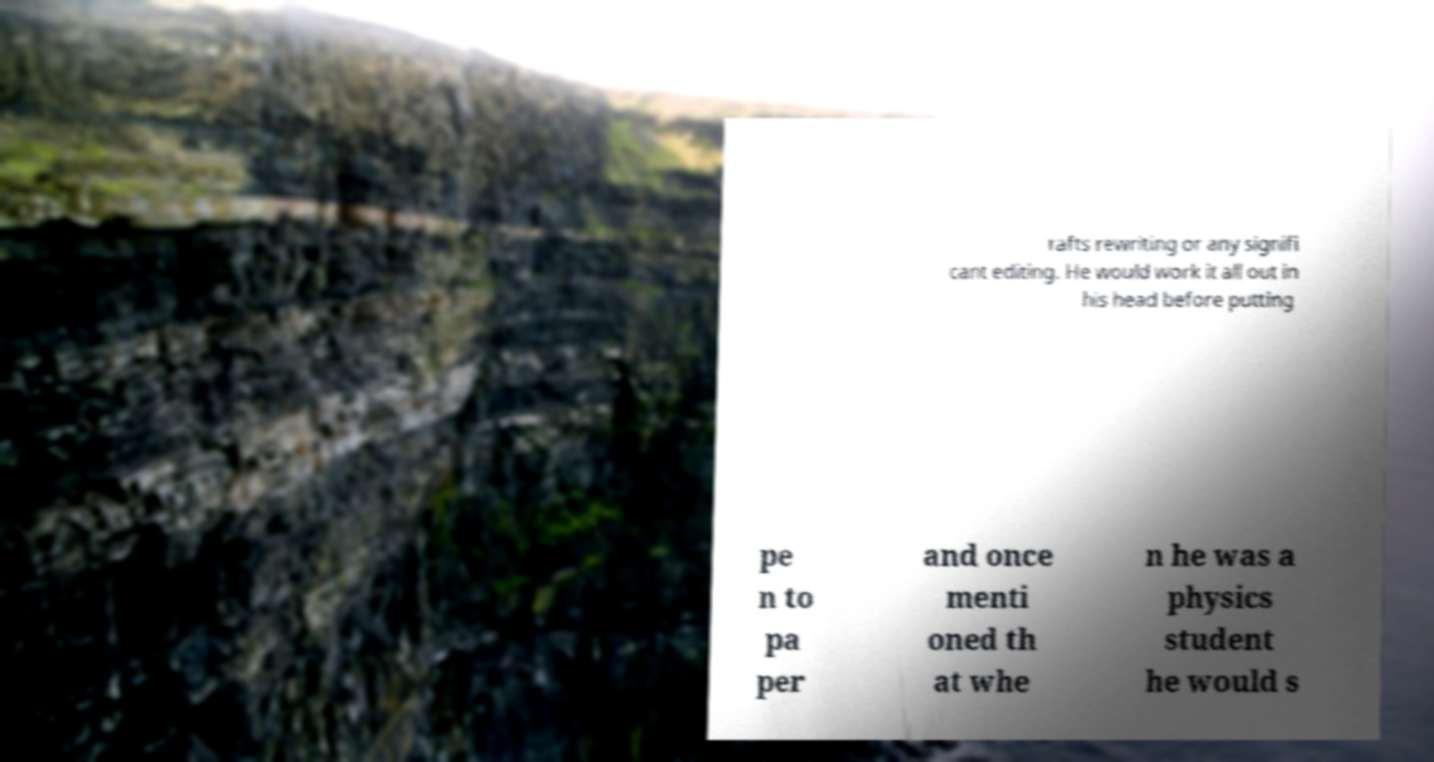Could you extract and type out the text from this image? rafts rewriting or any signifi cant editing. He would work it all out in his head before putting pe n to pa per and once menti oned th at whe n he was a physics student he would s 